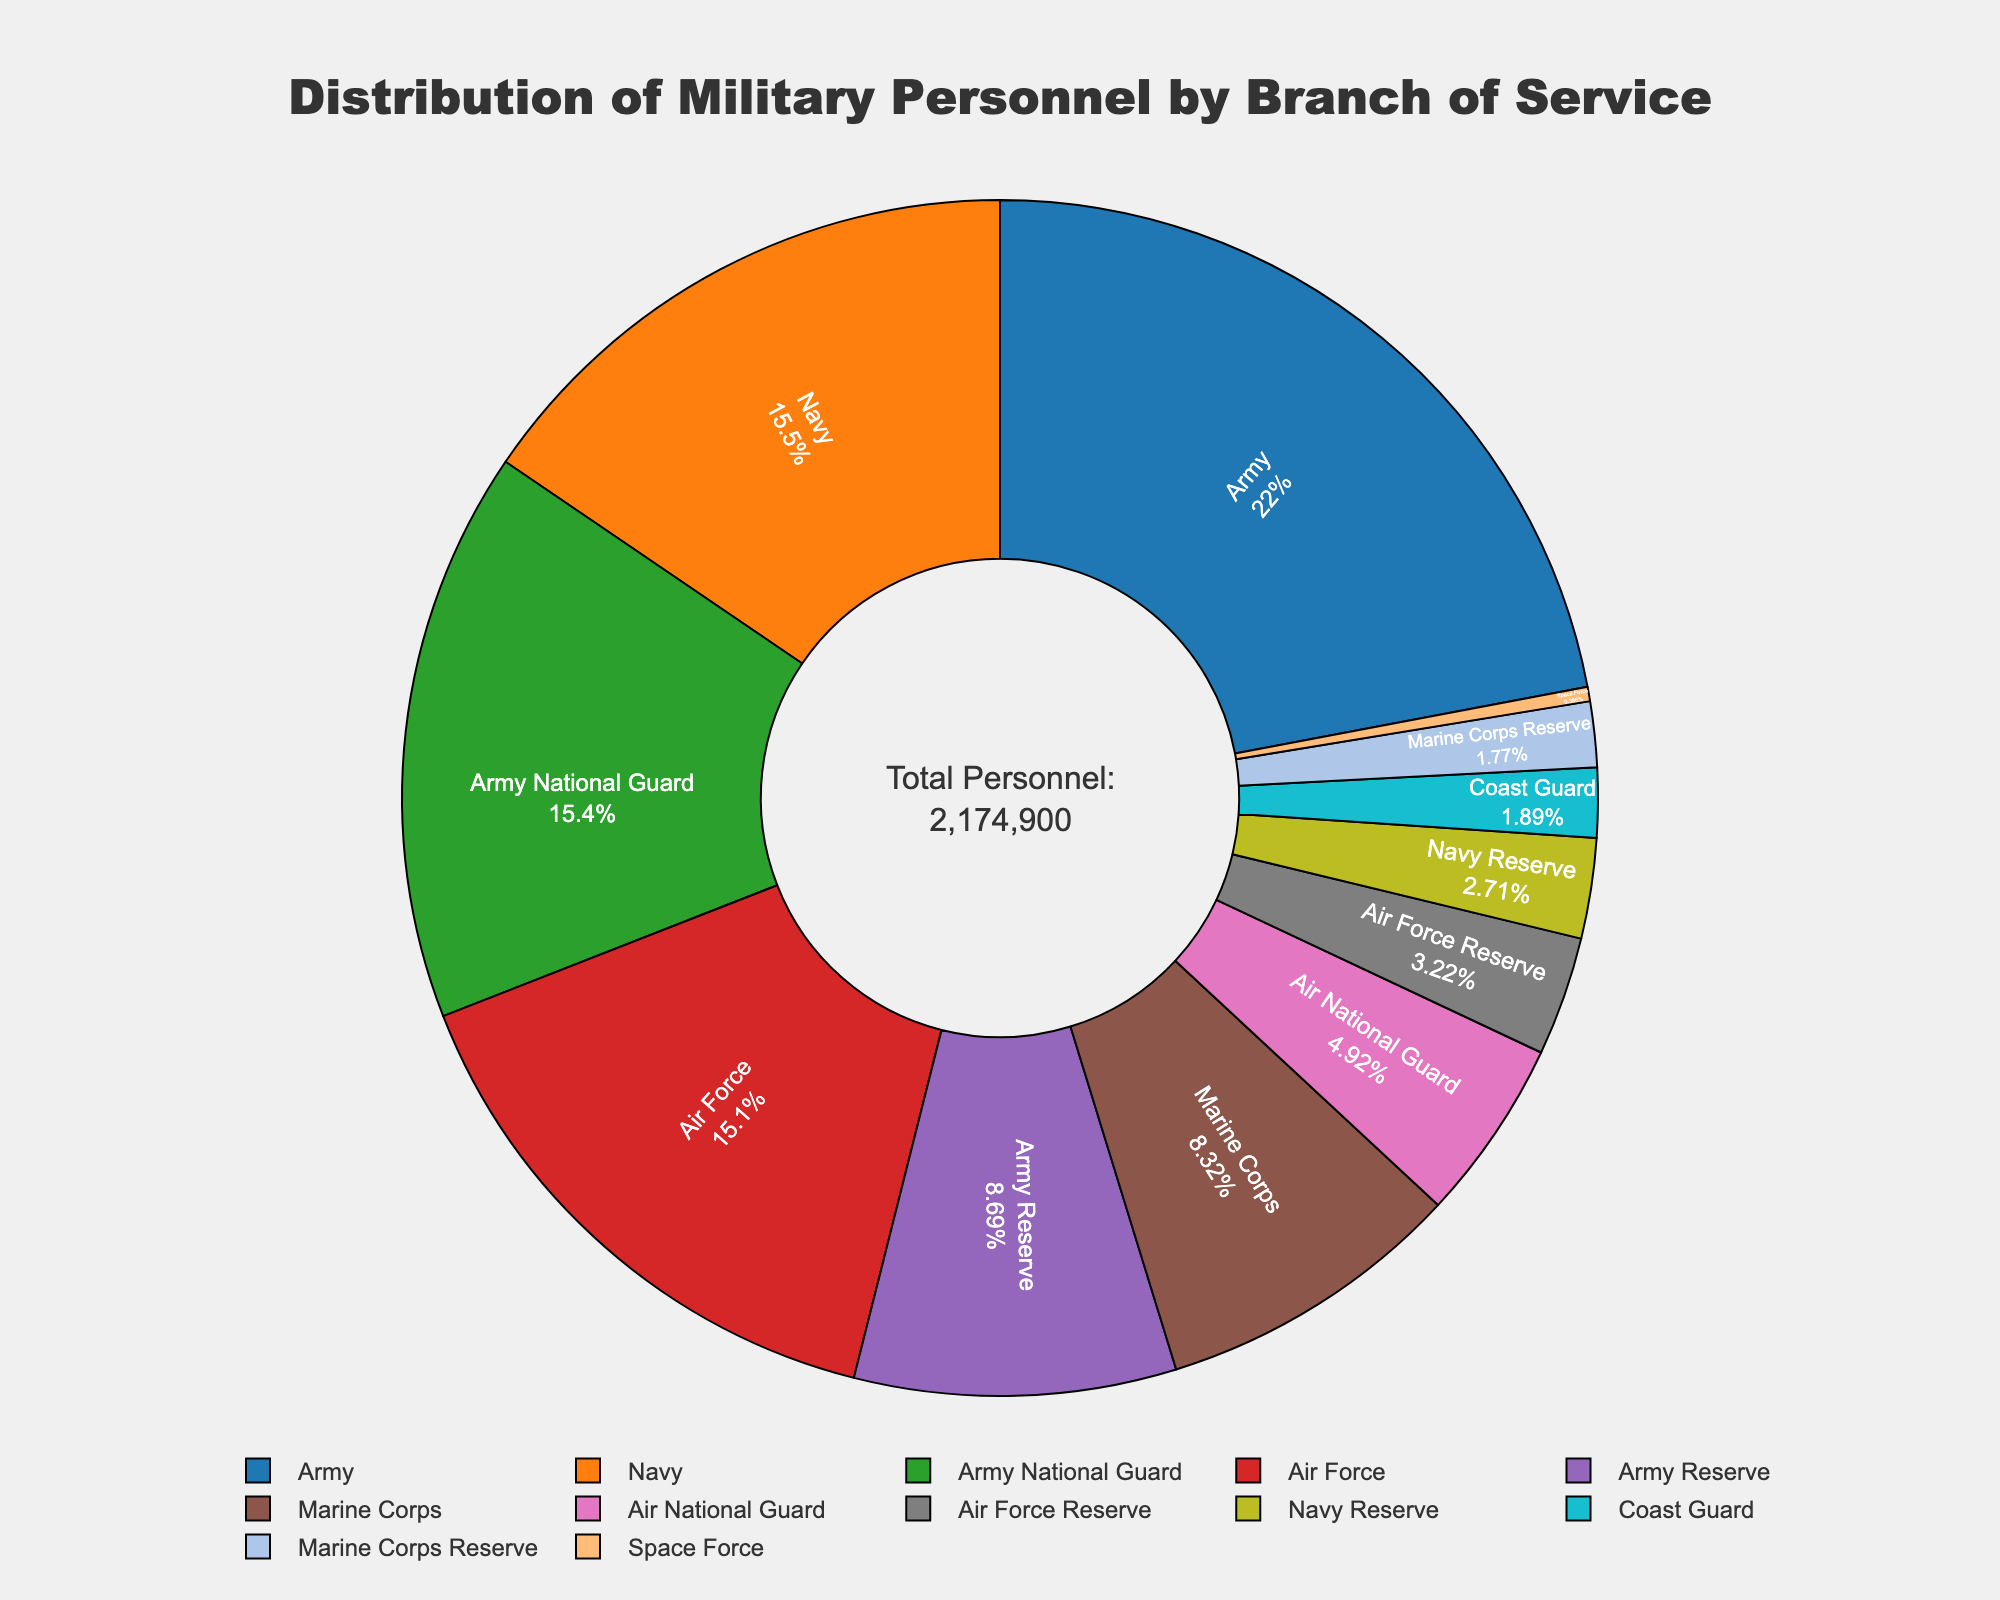Which branch has the highest number of personnel? The pie chart shows the Army has the largest segment, which indicates it has the highest number of personnel. The hover information reveals the Army has 479,000 personnel.
Answer: Army What percentage of total personnel is in the Navy? By hovering over the Navy segment, we see that the Navy makes up 17.1% of the total personnel. The total personnel count is provided in the annotation as 1,515,900.
Answer: 17.1% How many more personnel are in the Army National Guard compared to the Air National Guard? The Army National Guard has 336,000 personnel, while the Air National Guard has 107,000. Subtracting the latter from the former gives 229,000 more personnel in the Army National Guard.
Answer: 229,000 Which is greater, the combined personnel of the Marine Corps and the Air Force or the sum of the Army Reserve and the Navy Reserve? The Marine Corps has 181,000 and the Air Force has 329,000. Together they sum to 510,000. The Army Reserve has 189,000 and the Navy Reserve has 59,000, summing to 248,000. 510,000 is greater than 248,000.
Answer: Marine Corps and Air Force What is the color of the segment representing the Coast Guard? Visually inspecting the pie chart shows that the Coast Guard is represented by a segment colored brown.
Answer: Brown Which reserve component has the lowest number of personnel? From the pie chart, it can be seen that the Marine Corps Reserve has the smallest segment among the reserve components. The hover information shows it has 38,500 personnel.
Answer: Marine Corps Reserve How much is the difference in personnel between the Air Force and Navy? The Air Force has 329,000 personnel and the Navy has 337,000. Subtracting the Air Force personnel from the Navy personnel gives a difference of 8,000.
Answer: 8,000 What is the combined percentage of personnel in the Army and the Army National Guard? The Army makes up 31.6% and the Army National Guard makes up 22.2%. Combining these gives 53.8%.
Answer: 53.8% Which branch has fewer personnel, Space Force or the Air Force Reserve? Space Force has 8,400 personnel, whereas the Air Force Reserve has 70,000. Comparing these, Space Force has fewer personnel.
Answer: Space Force If you combine the personnel of the Coast Guard and Space Force, does this exceed the personnel count of the Marine Corps Reserve? The Coast Guard has 41,000 personnel, and Space Force has 8,400, summing to 49,400. The Marine Corps Reserve has 38,500, so the combined count of the Coast Guard and Space Force exceeds that of the Marine Corps Reserve.
Answer: Yes 